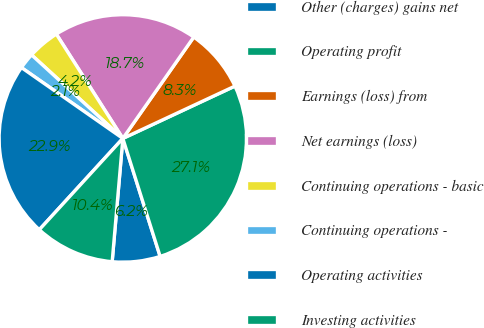<chart> <loc_0><loc_0><loc_500><loc_500><pie_chart><fcel>Other (charges) gains net<fcel>Operating profit<fcel>Earnings (loss) from<fcel>Net earnings (loss)<fcel>Continuing operations - basic<fcel>Continuing operations -<fcel>Operating activities<fcel>Investing activities<nl><fcel>6.25%<fcel>27.08%<fcel>8.33%<fcel>18.75%<fcel>4.17%<fcel>2.09%<fcel>22.91%<fcel>10.42%<nl></chart> 